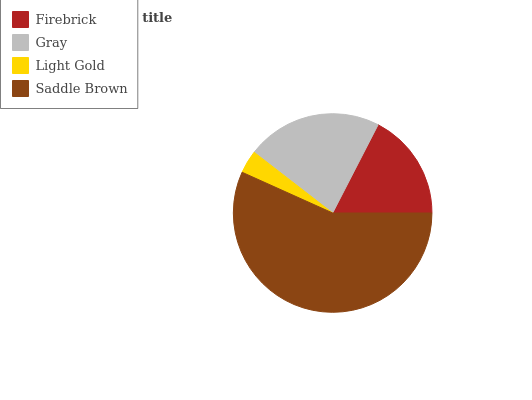Is Light Gold the minimum?
Answer yes or no. Yes. Is Saddle Brown the maximum?
Answer yes or no. Yes. Is Gray the minimum?
Answer yes or no. No. Is Gray the maximum?
Answer yes or no. No. Is Gray greater than Firebrick?
Answer yes or no. Yes. Is Firebrick less than Gray?
Answer yes or no. Yes. Is Firebrick greater than Gray?
Answer yes or no. No. Is Gray less than Firebrick?
Answer yes or no. No. Is Gray the high median?
Answer yes or no. Yes. Is Firebrick the low median?
Answer yes or no. Yes. Is Light Gold the high median?
Answer yes or no. No. Is Light Gold the low median?
Answer yes or no. No. 